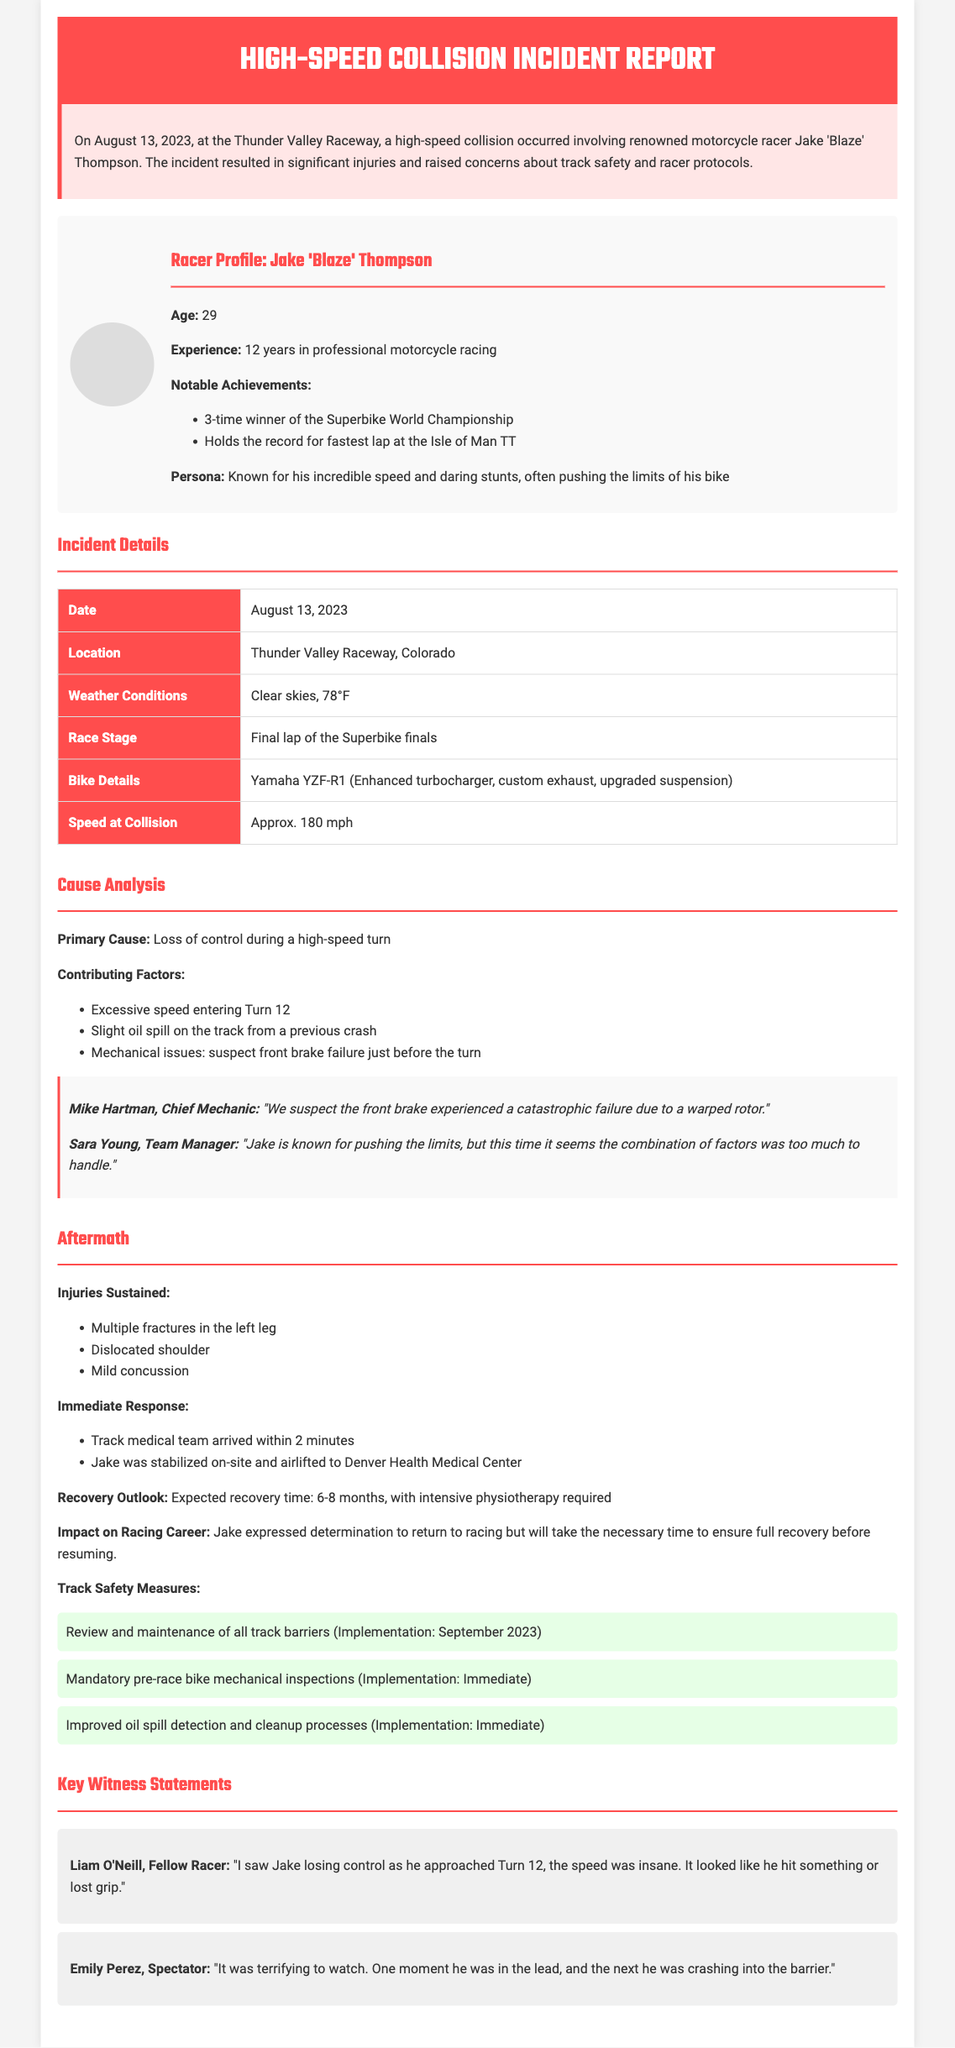What date did the collision occur? The date of the collision is specified in the incident summary section of the document.
Answer: August 13, 2023 What is Jake 'Blaze' Thompson's age? Jake 'Blaze' Thompson's age is provided in the racer profile section.
Answer: 29 What was the weather condition during the incident? The document states the weather conditions at the time of the incident in the incident details section.
Answer: Clear skies What was the speed at the time of the collision? The speed at which Jake 'Blaze' Thompson was traveling during the collision is provided in the incident details section.
Answer: Approx. 180 mph What injury did Jake sustain to his shoulder? The injuries sustained by Jake are listed in the aftermath section of the document.
Answer: Dislocated shoulder What was the primary cause of the collision? The primary cause is identified in the cause analysis section of the report.
Answer: Loss of control during a high-speed turn How long is Jake's expected recovery time? The document mentions the expected recovery time in the aftermath section.
Answer: 6-8 months What immediate response was taken by the track medical team? The immediate response taken by the medical team is detailed in the aftermath section of the report.
Answer: Arrived within 2 minutes What will be implemented for track safety measures? The track safety measures proposed are listed in the aftermath section of the document.
Answer: Review and maintenance of all track barriers 